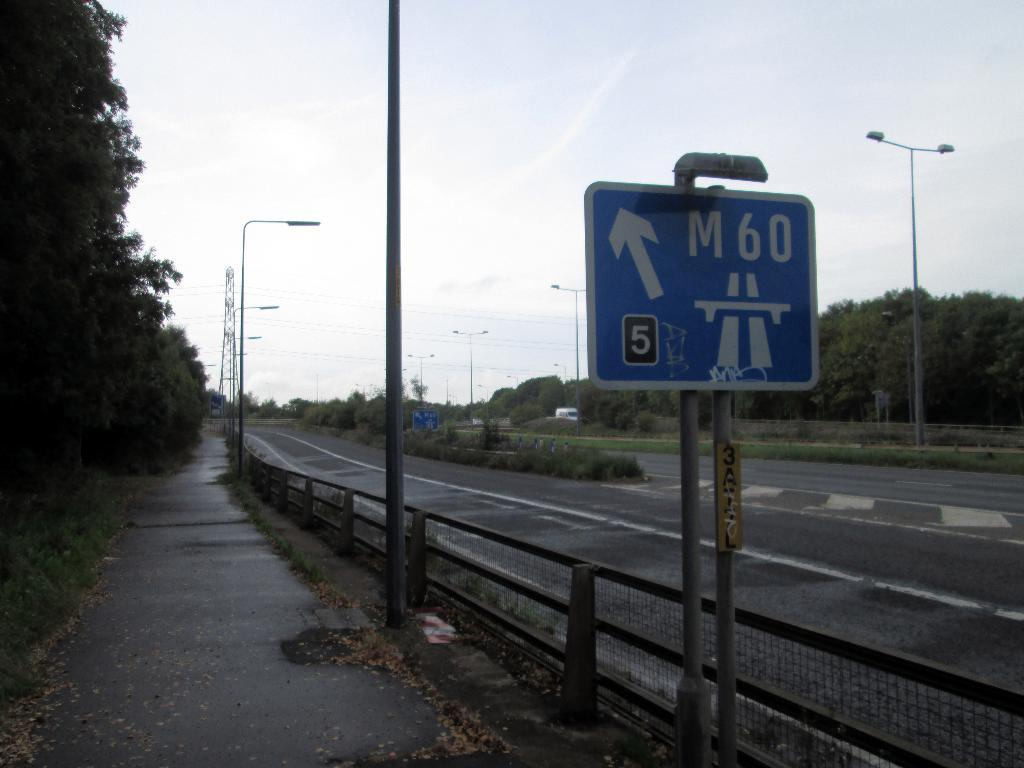Provide a one-sentence caption for the provided image. A view of a highway with a sign pointing to the M60 exit in 5 kilometers. 